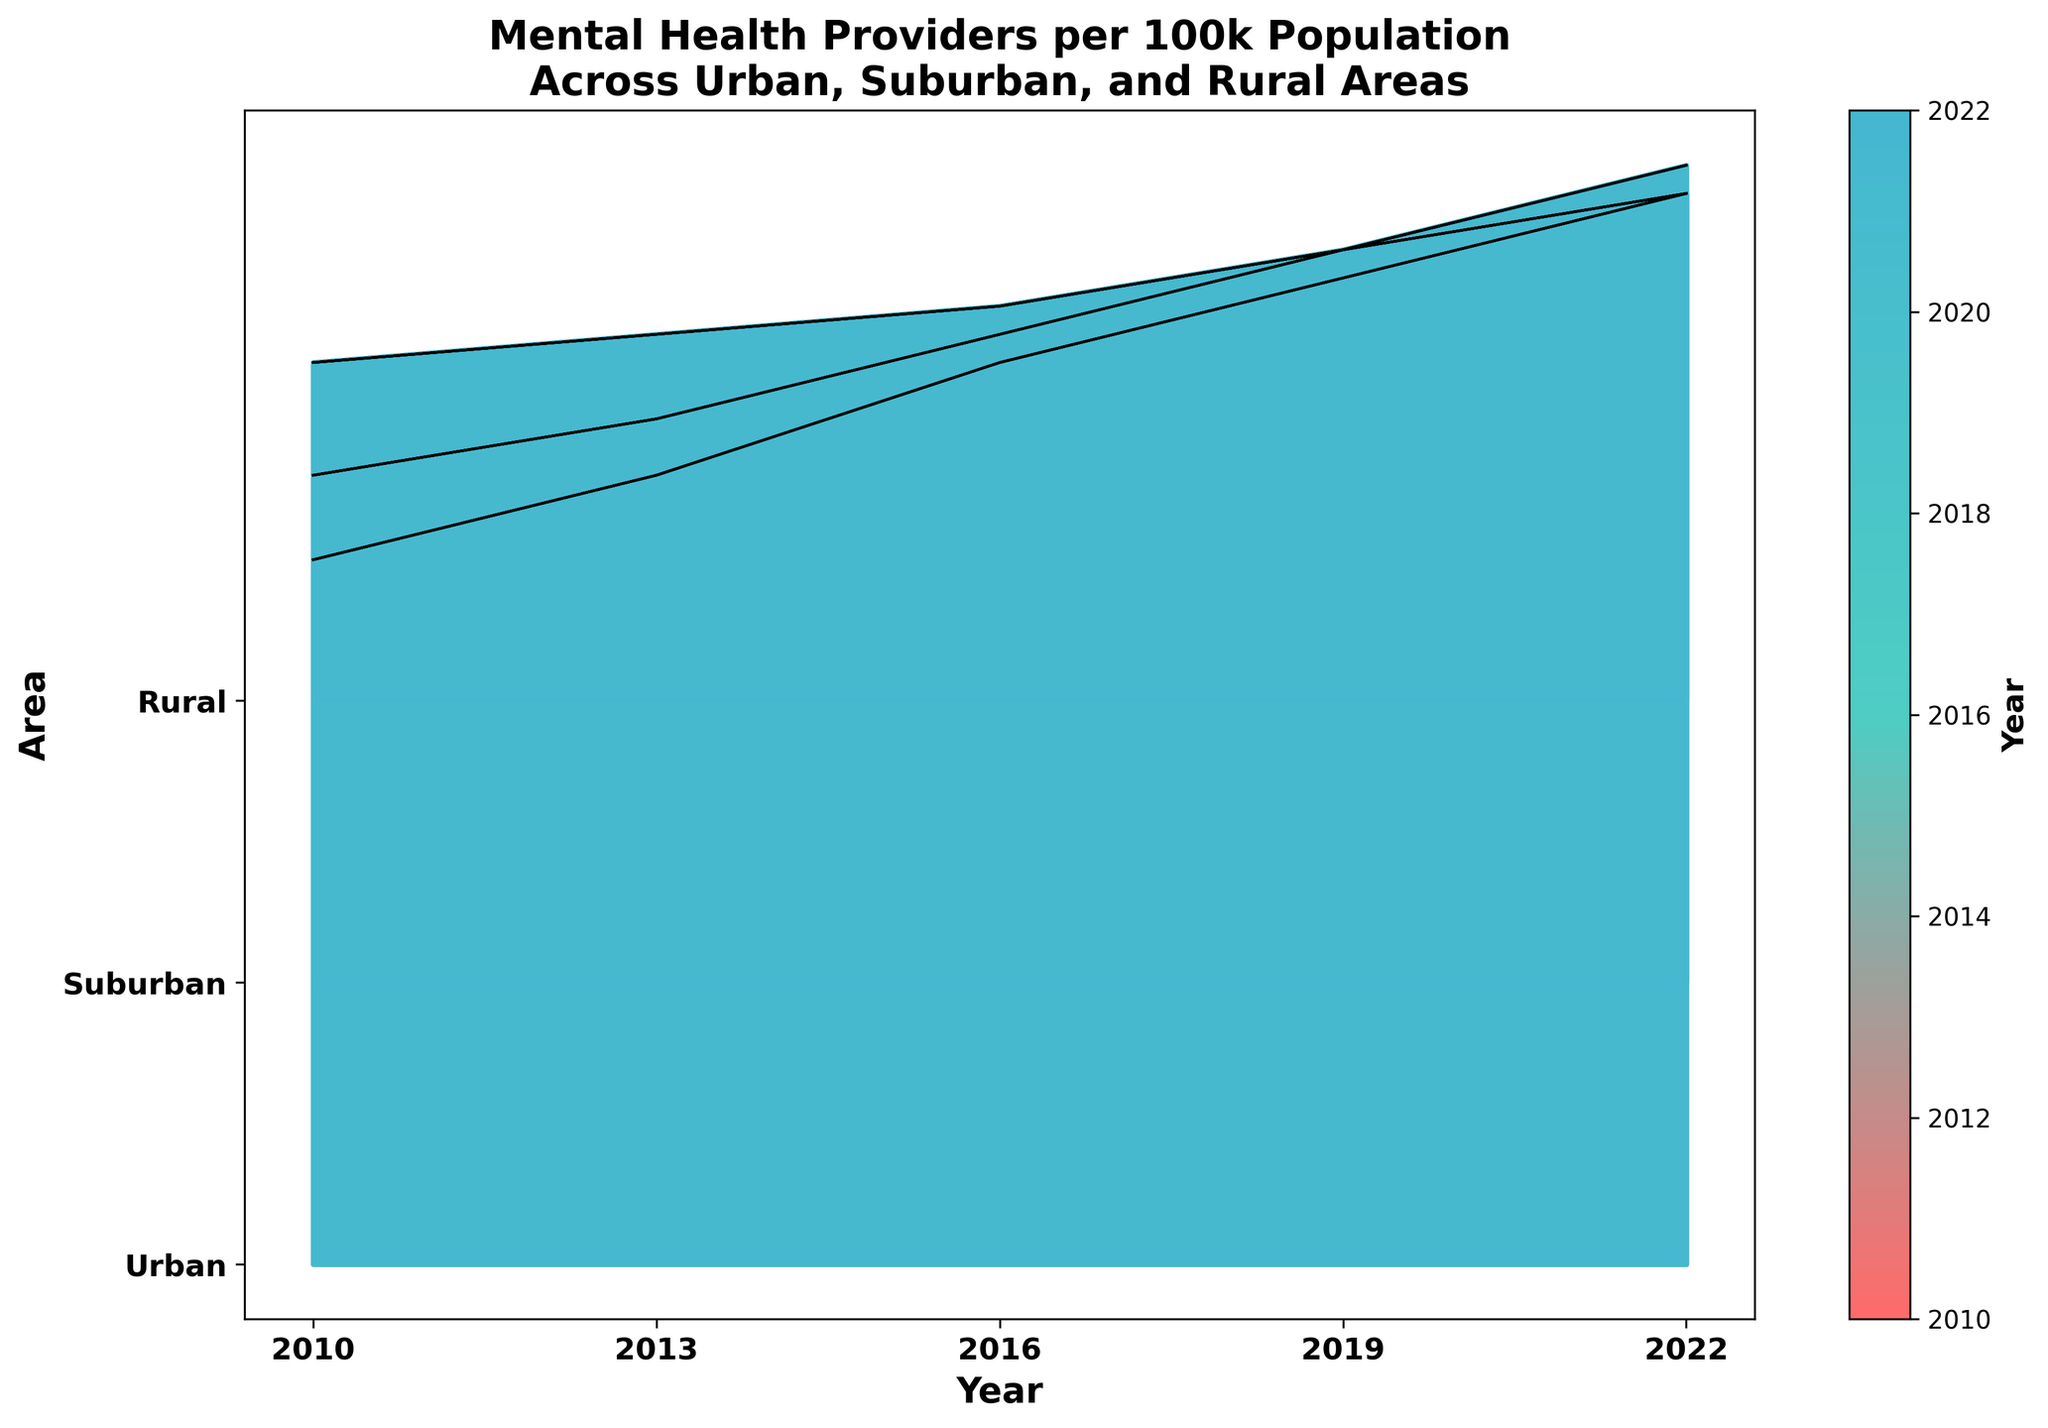What is the title of the figure? The title is written in the largest font at the top of the figure. It usually summarizes what the plot represents.
Answer: Mental Health Providers per 100k Population Across Urban, Suburban, and Rural Areas How many areas are compared in the figure? The y-axis labels represent the different areas being compared in the plot. Count the unique labels shown there.
Answer: 3 Which area had the highest number of mental health providers per 100k in 2010? Move along the x-axis to the point corresponding to 2010 and identify the area with the highest peak value on the graph for that year.
Answer: Urban What trend is observed for Suburban areas in terms of mental health providers per 100k from 2010 to 2022? Follow the plotted line and filled area corresponding to Suburban areas across the x-axis from 2010 to 2022. Note if the line generally trends upwards, downwards, or remains stable.
Answer: Upward trend Which color on the plot represents the early years (like 2010)? Identify the fill colors used in the plot and look for which one is more towards the lower end of the color spectrum.
Answer: Red shades By how much did the number of mental health providers per 100k in Rural areas increase from 2016 to 2022? Identify the peak values for Rural areas in 2016 and 2022, then subtract the 2016 value from the 2022 value.
Answer: 4 (18 in 2022 - 14 in 2016) Which area shows the most significant improvement in mental health providers per 100k over the entire period? Compare the trend lines for all three areas and identify which has the steepest overall increase from the beginning to the end of the timeline.
Answer: Urban How does the number of mental health providers per 100k in Rural areas in 2019 compare to Urban areas in the same year? Locate 2019 on the x-axis and compare the peak values for Rural and Urban areas from the plot for that year.
Answer: Urban is higher What color represents the latest years like 2022 in the plot? Identify the color used toward the end of the x-axis, which typically uses a color gradient representing the most recent data.
Answer: Blue shades 